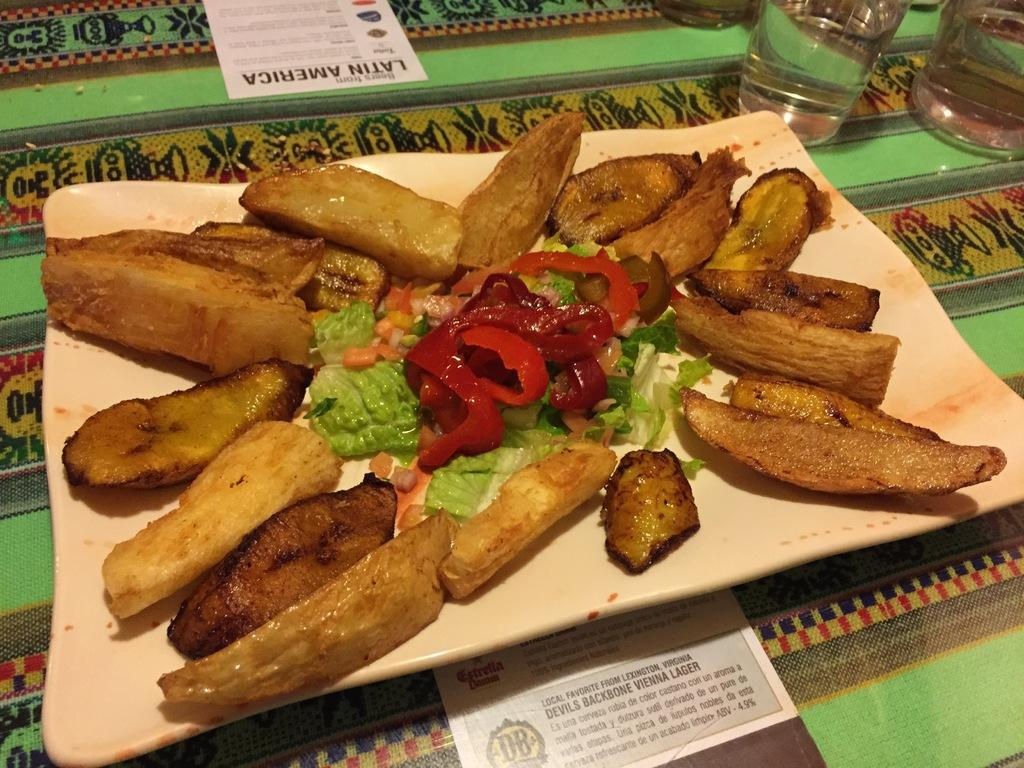What is on the plate that is visible in the image? There is a plate containing food in the image. Where is the plate located in the image? The plate is placed on a surface. What can be seen in the background of the image? There are glasses and papers with text in the background of the image. What type of view can be seen through the glasses in the image? There are no views visible through the glasses in the image; they are simply glasses in the background. 